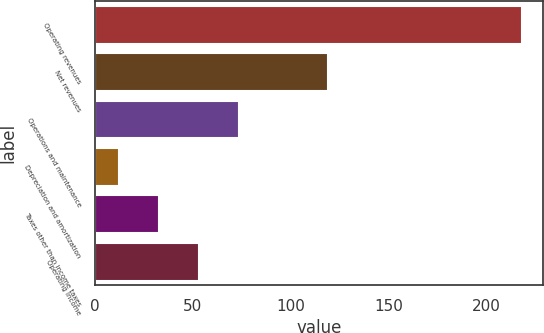Convert chart. <chart><loc_0><loc_0><loc_500><loc_500><bar_chart><fcel>Operating revenues<fcel>Net revenues<fcel>Operations and maintenance<fcel>Depreciation and amortization<fcel>Taxes other than income taxes<fcel>Operating income<nl><fcel>218<fcel>119<fcel>73.8<fcel>12<fcel>32.6<fcel>53.2<nl></chart> 